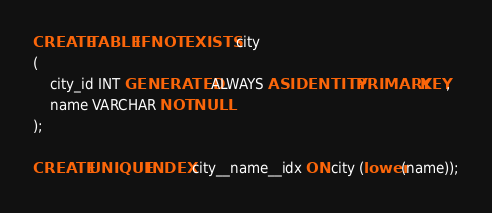<code> <loc_0><loc_0><loc_500><loc_500><_SQL_>CREATE TABLE IF NOT EXISTS city
(
    city_id INT GENERATED ALWAYS AS IDENTITY PRIMARY KEY,
    name VARCHAR NOT NULL
);

CREATE UNIQUE INDEX city__name__idx ON city (lower(name));
</code> 